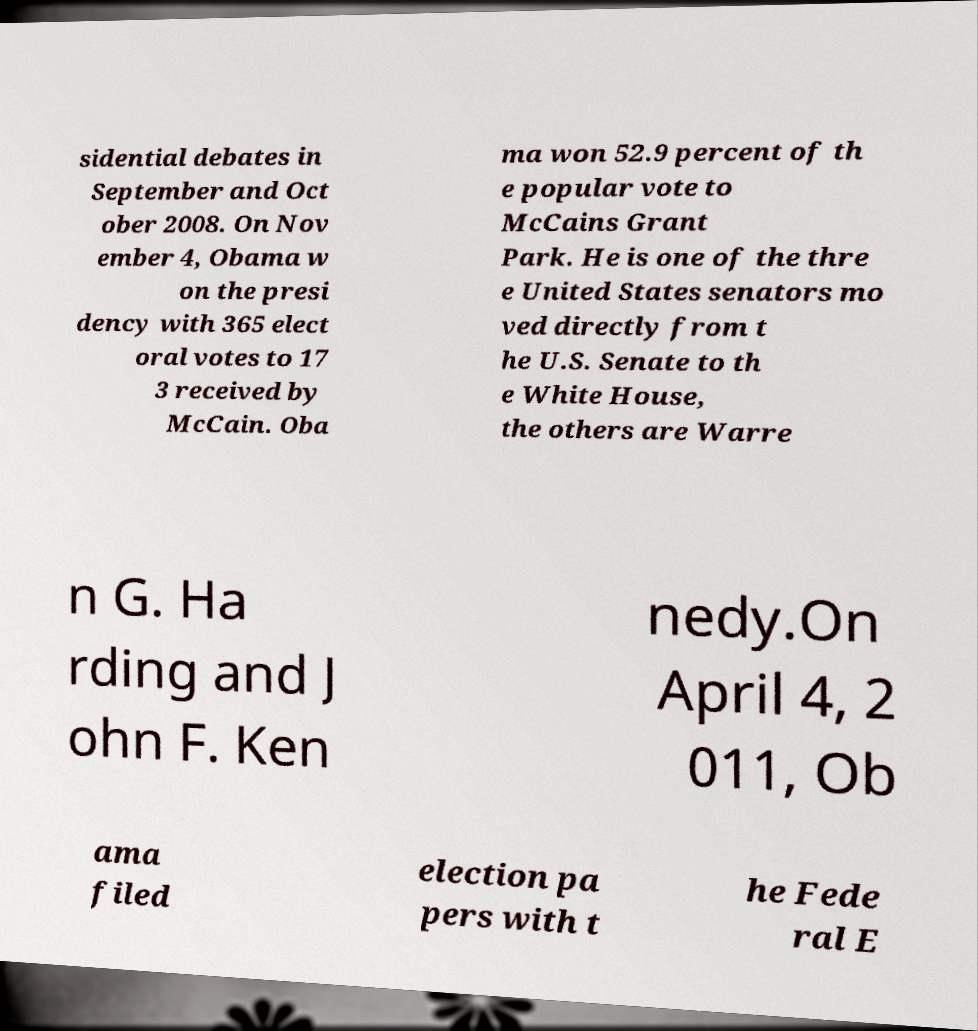Could you extract and type out the text from this image? sidential debates in September and Oct ober 2008. On Nov ember 4, Obama w on the presi dency with 365 elect oral votes to 17 3 received by McCain. Oba ma won 52.9 percent of th e popular vote to McCains Grant Park. He is one of the thre e United States senators mo ved directly from t he U.S. Senate to th e White House, the others are Warre n G. Ha rding and J ohn F. Ken nedy.On April 4, 2 011, Ob ama filed election pa pers with t he Fede ral E 